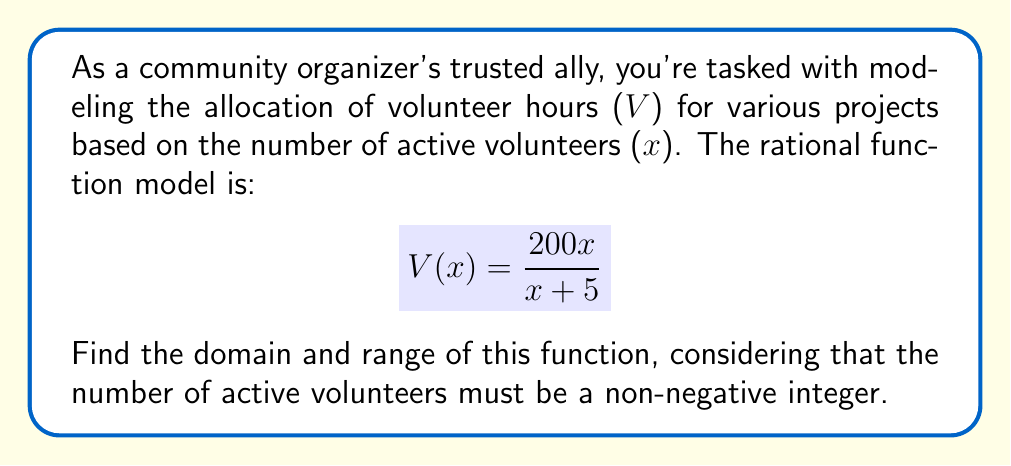Give your solution to this math problem. 1. Domain:
   - The denominator cannot be zero, so $x + 5 \neq 0$
   - Solve for x: $x \neq -5$
   - Since x represents the number of active volunteers, it must be non-negative and an integer.
   - Therefore, the domain is all non-negative integers: $x \in \{0, 1, 2, 3, ...\}$

2. Range:
   - To find the range, let's analyze the behavior of the function:
     a) As $x$ approaches infinity, $V(x)$ approaches 200:
        $\lim_{x \to \infty} \frac{200x}{x + 5} = 200$
     b) When $x = 0$, $V(0) = 0$
   - The function is continuous and increasing for all $x \geq 0$
   - For any integer $x \geq 0$, $0 \leq V(x) < 200$

3. Considering discrete values:
   - The function will never exactly reach 200, as x is restricted to integers
   - The largest possible value will be slightly less than 200

Therefore, the range consists of all values $V(x)$ where $x$ is a non-negative integer, forming a discrete set of points between 0 and 200 (exclusive).
Answer: Domain: $\{x \in \mathbb{Z} : x \geq 0\}$
Range: $\{V(x) : x \in \mathbb{Z}, x \geq 0, 0 \leq V(x) < 200\}$ 